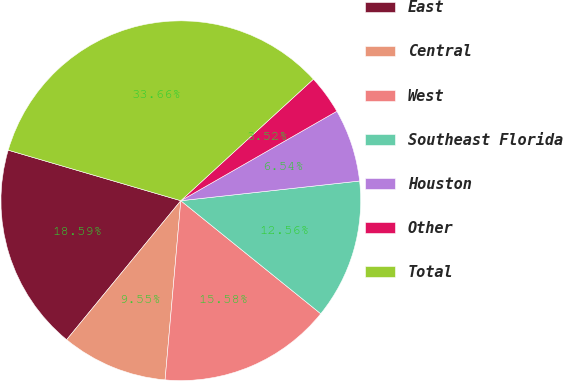Convert chart. <chart><loc_0><loc_0><loc_500><loc_500><pie_chart><fcel>East<fcel>Central<fcel>West<fcel>Southeast Florida<fcel>Houston<fcel>Other<fcel>Total<nl><fcel>18.59%<fcel>9.55%<fcel>15.58%<fcel>12.56%<fcel>6.54%<fcel>3.52%<fcel>33.66%<nl></chart> 